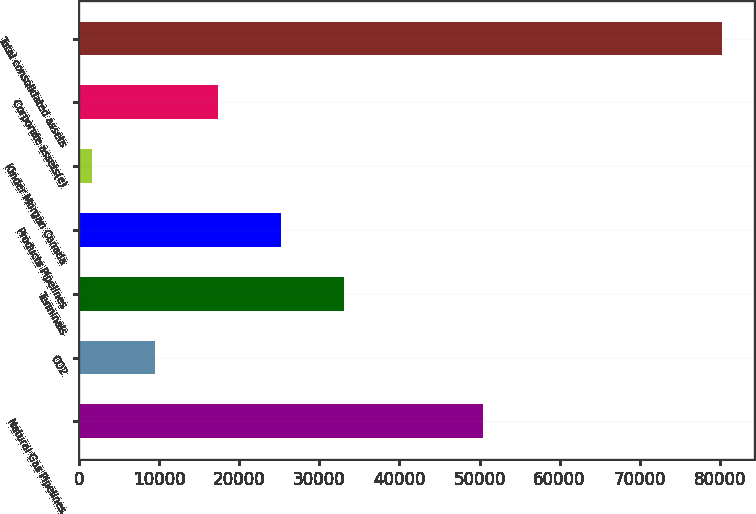Convert chart to OTSL. <chart><loc_0><loc_0><loc_500><loc_500><bar_chart><fcel>Natural Gas Pipelines<fcel>CO2<fcel>Terminals<fcel>Products Pipelines<fcel>Kinder Morgan Canada<fcel>Corporate assets(e)<fcel>Total consolidated assets<nl><fcel>50428<fcel>9445.3<fcel>33065.2<fcel>25191.9<fcel>1572<fcel>17318.6<fcel>80305<nl></chart> 